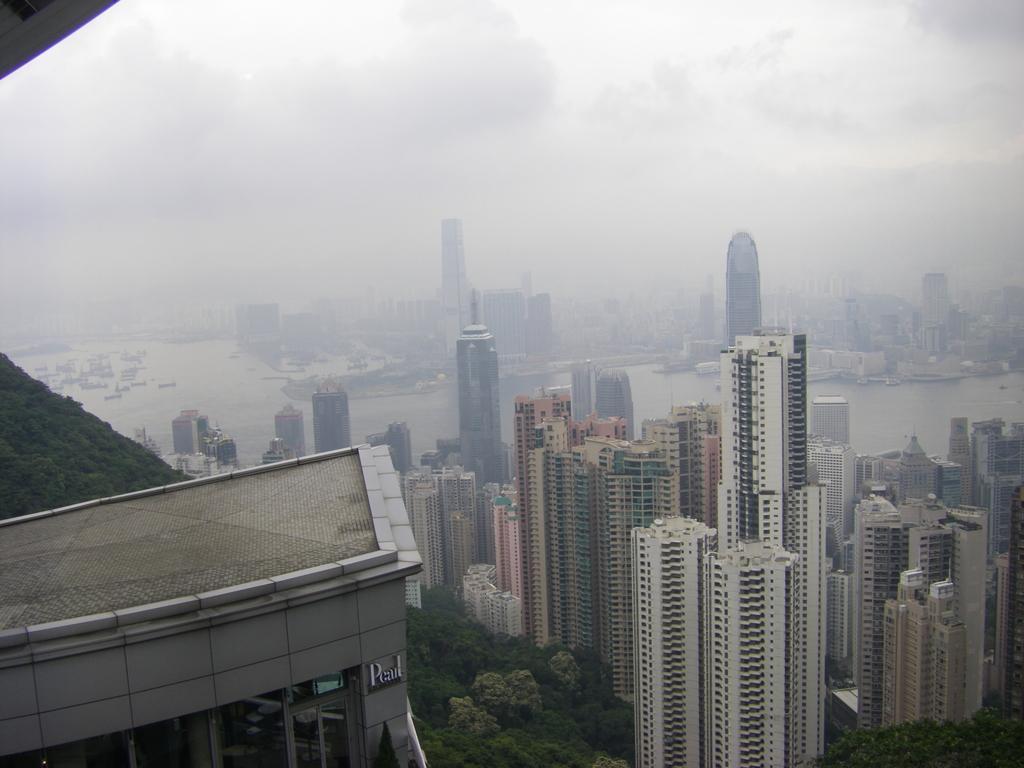How would you summarize this image in a sentence or two? In the foreground of this image, there is a building on the left. Behind it, there is greenery and skyscrapers. In the background, there are buildings, water, ships and the sky. 